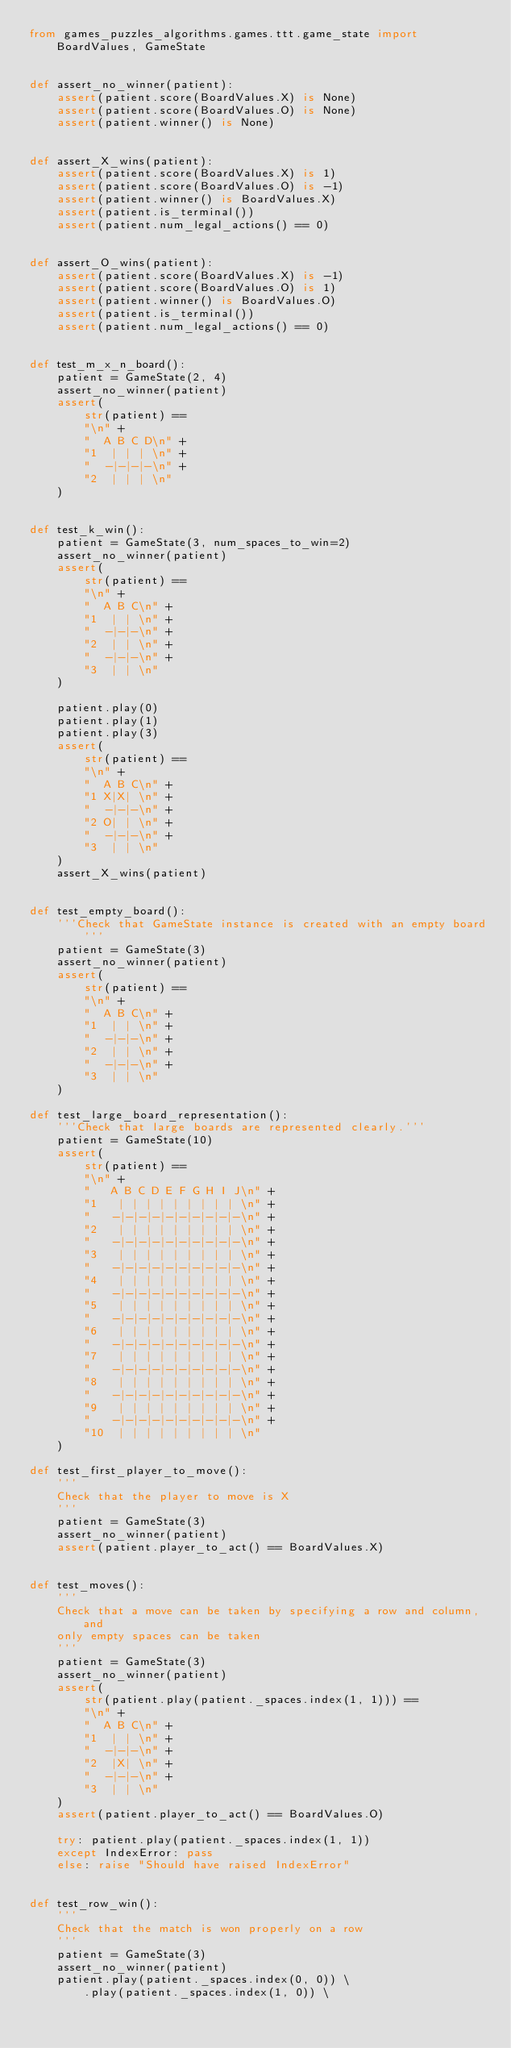<code> <loc_0><loc_0><loc_500><loc_500><_Python_>from games_puzzles_algorithms.games.ttt.game_state import BoardValues, GameState


def assert_no_winner(patient):
    assert(patient.score(BoardValues.X) is None)
    assert(patient.score(BoardValues.O) is None)
    assert(patient.winner() is None)


def assert_X_wins(patient):
    assert(patient.score(BoardValues.X) is 1)
    assert(patient.score(BoardValues.O) is -1)
    assert(patient.winner() is BoardValues.X)
    assert(patient.is_terminal())
    assert(patient.num_legal_actions() == 0)


def assert_O_wins(patient):
    assert(patient.score(BoardValues.X) is -1)
    assert(patient.score(BoardValues.O) is 1)
    assert(patient.winner() is BoardValues.O)
    assert(patient.is_terminal())
    assert(patient.num_legal_actions() == 0)


def test_m_x_n_board():
    patient = GameState(2, 4)
    assert_no_winner(patient)
    assert(
        str(patient) ==
        "\n" +
        "  A B C D\n" +
        "1  | | | \n" +
        "  -|-|-|-\n" +
        "2  | | | \n"
    )


def test_k_win():
    patient = GameState(3, num_spaces_to_win=2)
    assert_no_winner(patient)
    assert(
        str(patient) ==
        "\n" +
        "  A B C\n" +
        "1  | | \n" +
        "  -|-|-\n" +
        "2  | | \n" +
        "  -|-|-\n" +
        "3  | | \n"
    )

    patient.play(0)
    patient.play(1)
    patient.play(3)
    assert(
        str(patient) ==
        "\n" +
        "  A B C\n" +
        "1 X|X| \n" +
        "  -|-|-\n" +
        "2 O| | \n" +
        "  -|-|-\n" +
        "3  | | \n"
    )
    assert_X_wins(patient)


def test_empty_board():
    '''Check that GameState instance is created with an empty board'''
    patient = GameState(3)
    assert_no_winner(patient)
    assert(
        str(patient) ==
        "\n" +
        "  A B C\n" +
        "1  | | \n" +
        "  -|-|-\n" +
        "2  | | \n" +
        "  -|-|-\n" +
        "3  | | \n"
    )

def test_large_board_representation():
    '''Check that large boards are represented clearly.'''
    patient = GameState(10)
    assert(
        str(patient) ==
        "\n" +
        "   A B C D E F G H I J\n" +
        "1   | | | | | | | | | \n" +
        "   -|-|-|-|-|-|-|-|-|-\n" +
        "2   | | | | | | | | | \n" +
        "   -|-|-|-|-|-|-|-|-|-\n" +
        "3   | | | | | | | | | \n" +
        "   -|-|-|-|-|-|-|-|-|-\n" +
        "4   | | | | | | | | | \n" +
        "   -|-|-|-|-|-|-|-|-|-\n" +
        "5   | | | | | | | | | \n" +
        "   -|-|-|-|-|-|-|-|-|-\n" +
        "6   | | | | | | | | | \n" +
        "   -|-|-|-|-|-|-|-|-|-\n" +
        "7   | | | | | | | | | \n" +
        "   -|-|-|-|-|-|-|-|-|-\n" +
        "8   | | | | | | | | | \n" +
        "   -|-|-|-|-|-|-|-|-|-\n" +
        "9   | | | | | | | | | \n" +
        "   -|-|-|-|-|-|-|-|-|-\n" +
        "10  | | | | | | | | | \n"
    )

def test_first_player_to_move():
    '''
    Check that the player to move is X
    '''
    patient = GameState(3)
    assert_no_winner(patient)
    assert(patient.player_to_act() == BoardValues.X)


def test_moves():
    '''
    Check that a move can be taken by specifying a row and column, and
    only empty spaces can be taken
    '''
    patient = GameState(3)
    assert_no_winner(patient)
    assert(
        str(patient.play(patient._spaces.index(1, 1))) ==
        "\n" +
        "  A B C\n" +
        "1  | | \n" +
        "  -|-|-\n" +
        "2  |X| \n" +
        "  -|-|-\n" +
        "3  | | \n"
    )
    assert(patient.player_to_act() == BoardValues.O)

    try: patient.play(patient._spaces.index(1, 1))
    except IndexError: pass
    else: raise "Should have raised IndexError"


def test_row_win():
    '''
    Check that the match is won properly on a row
    '''
    patient = GameState(3)
    assert_no_winner(patient)
    patient.play(patient._spaces.index(0, 0)) \
        .play(patient._spaces.index(1, 0)) \</code> 